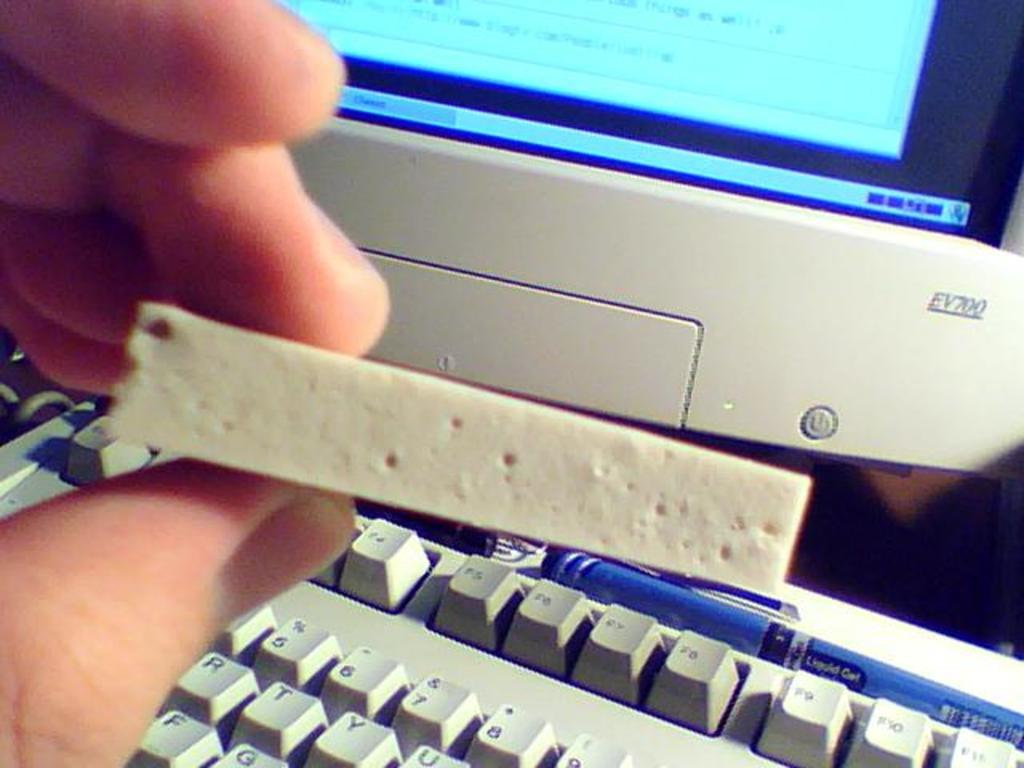<image>
Provide a brief description of the given image. A hand holds a cream colored rectangular object with holes in it, in front of a monitor labeled EV700. 